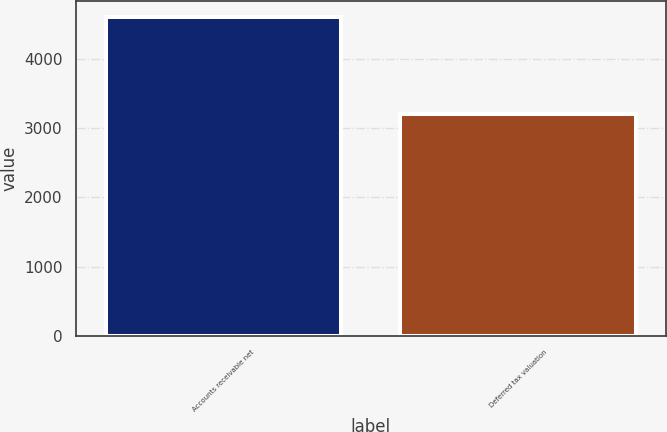Convert chart to OTSL. <chart><loc_0><loc_0><loc_500><loc_500><bar_chart><fcel>Accounts receivable net<fcel>Deferred tax valuation<nl><fcel>4613<fcel>3200<nl></chart> 